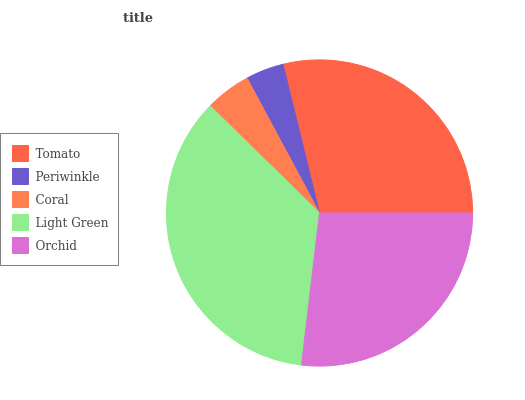Is Periwinkle the minimum?
Answer yes or no. Yes. Is Light Green the maximum?
Answer yes or no. Yes. Is Coral the minimum?
Answer yes or no. No. Is Coral the maximum?
Answer yes or no. No. Is Coral greater than Periwinkle?
Answer yes or no. Yes. Is Periwinkle less than Coral?
Answer yes or no. Yes. Is Periwinkle greater than Coral?
Answer yes or no. No. Is Coral less than Periwinkle?
Answer yes or no. No. Is Orchid the high median?
Answer yes or no. Yes. Is Orchid the low median?
Answer yes or no. Yes. Is Coral the high median?
Answer yes or no. No. Is Light Green the low median?
Answer yes or no. No. 